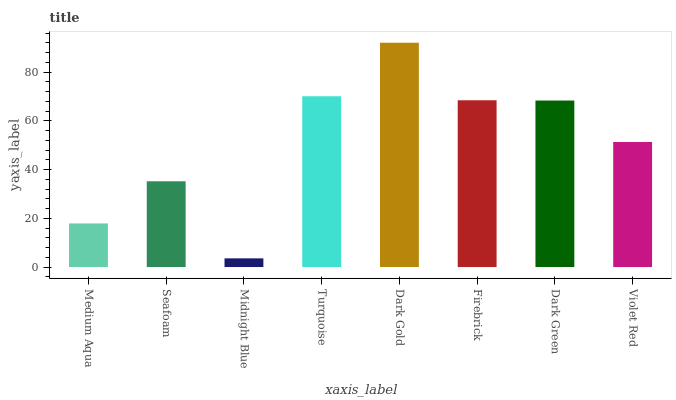Is Midnight Blue the minimum?
Answer yes or no. Yes. Is Dark Gold the maximum?
Answer yes or no. Yes. Is Seafoam the minimum?
Answer yes or no. No. Is Seafoam the maximum?
Answer yes or no. No. Is Seafoam greater than Medium Aqua?
Answer yes or no. Yes. Is Medium Aqua less than Seafoam?
Answer yes or no. Yes. Is Medium Aqua greater than Seafoam?
Answer yes or no. No. Is Seafoam less than Medium Aqua?
Answer yes or no. No. Is Dark Green the high median?
Answer yes or no. Yes. Is Violet Red the low median?
Answer yes or no. Yes. Is Midnight Blue the high median?
Answer yes or no. No. Is Seafoam the low median?
Answer yes or no. No. 